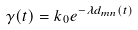Convert formula to latex. <formula><loc_0><loc_0><loc_500><loc_500>\gamma ( t ) = k _ { 0 } e ^ { - \lambda d _ { m n } ( t ) }</formula> 